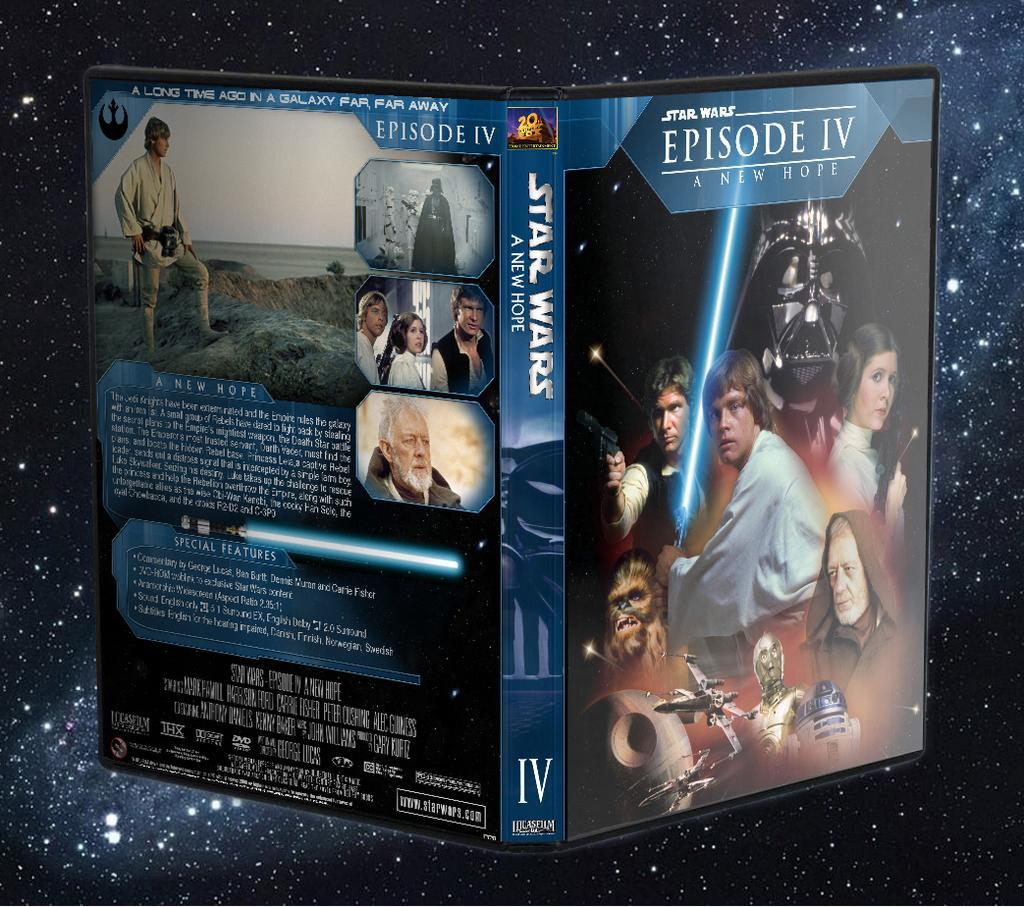Can you describe this image briefly? In this picture there is an object which has few images and some thing written on it and there is star wars a new hope written in middle of it and there are few white lights on the black surface in the background. 